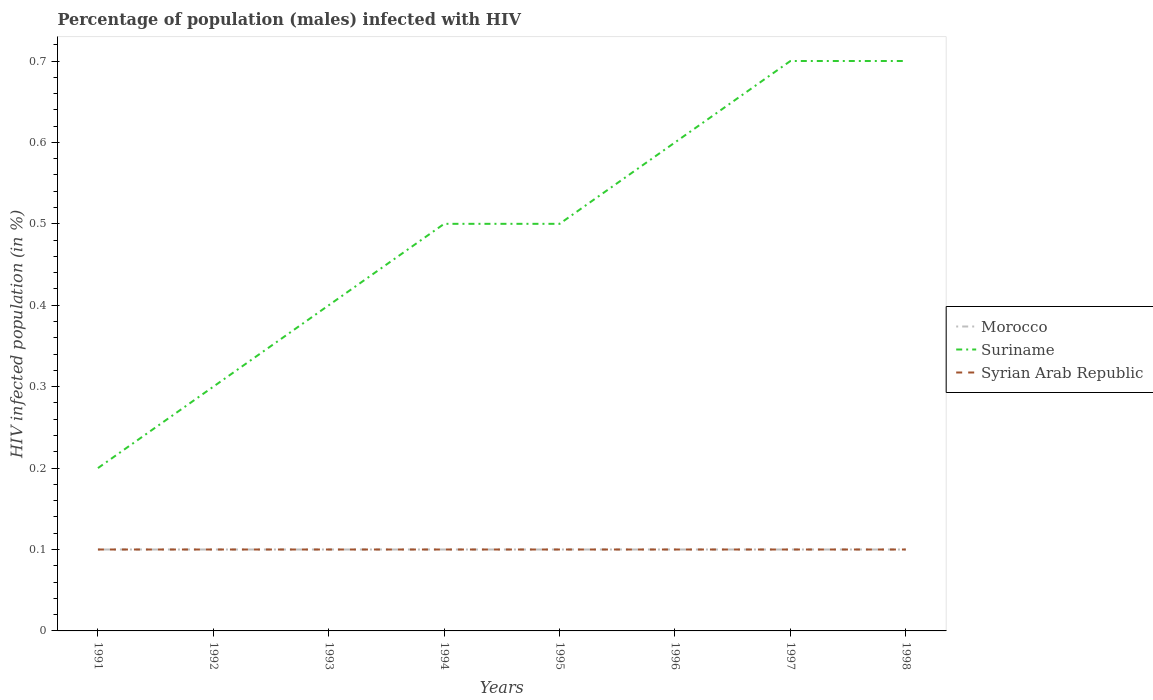Is the number of lines equal to the number of legend labels?
Your answer should be compact. Yes. Across all years, what is the maximum percentage of HIV infected male population in Suriname?
Your response must be concise. 0.2. In which year was the percentage of HIV infected male population in Suriname maximum?
Make the answer very short. 1991. What is the total percentage of HIV infected male population in Suriname in the graph?
Give a very brief answer. -0.1. What is the difference between the highest and the second highest percentage of HIV infected male population in Syrian Arab Republic?
Your answer should be very brief. 0. What is the difference between the highest and the lowest percentage of HIV infected male population in Syrian Arab Republic?
Your response must be concise. 0. Is the percentage of HIV infected male population in Syrian Arab Republic strictly greater than the percentage of HIV infected male population in Morocco over the years?
Your response must be concise. No. How many lines are there?
Ensure brevity in your answer.  3. How many years are there in the graph?
Ensure brevity in your answer.  8. What is the difference between two consecutive major ticks on the Y-axis?
Offer a terse response. 0.1. Does the graph contain any zero values?
Provide a short and direct response. No. How are the legend labels stacked?
Provide a succinct answer. Vertical. What is the title of the graph?
Make the answer very short. Percentage of population (males) infected with HIV. What is the label or title of the Y-axis?
Make the answer very short. HIV infected population (in %). What is the HIV infected population (in %) of Morocco in 1991?
Offer a terse response. 0.1. What is the HIV infected population (in %) of Suriname in 1992?
Provide a short and direct response. 0.3. What is the HIV infected population (in %) in Syrian Arab Republic in 1992?
Offer a terse response. 0.1. What is the HIV infected population (in %) of Morocco in 1993?
Your answer should be compact. 0.1. What is the HIV infected population (in %) in Syrian Arab Republic in 1993?
Provide a short and direct response. 0.1. What is the HIV infected population (in %) in Suriname in 1994?
Give a very brief answer. 0.5. What is the HIV infected population (in %) in Syrian Arab Republic in 1994?
Provide a short and direct response. 0.1. What is the HIV infected population (in %) in Suriname in 1995?
Make the answer very short. 0.5. What is the HIV infected population (in %) of Syrian Arab Republic in 1996?
Your response must be concise. 0.1. What is the HIV infected population (in %) in Morocco in 1997?
Offer a very short reply. 0.1. What is the HIV infected population (in %) in Suriname in 1997?
Ensure brevity in your answer.  0.7. What is the HIV infected population (in %) in Syrian Arab Republic in 1997?
Offer a very short reply. 0.1. What is the HIV infected population (in %) in Morocco in 1998?
Your response must be concise. 0.1. What is the HIV infected population (in %) in Suriname in 1998?
Make the answer very short. 0.7. Across all years, what is the maximum HIV infected population (in %) of Morocco?
Provide a succinct answer. 0.1. Across all years, what is the minimum HIV infected population (in %) in Syrian Arab Republic?
Provide a short and direct response. 0.1. What is the total HIV infected population (in %) of Morocco in the graph?
Offer a terse response. 0.8. What is the total HIV infected population (in %) of Suriname in the graph?
Your answer should be very brief. 3.9. What is the difference between the HIV infected population (in %) of Suriname in 1991 and that in 1992?
Provide a short and direct response. -0.1. What is the difference between the HIV infected population (in %) of Syrian Arab Republic in 1991 and that in 1992?
Offer a very short reply. 0. What is the difference between the HIV infected population (in %) of Suriname in 1991 and that in 1993?
Your answer should be compact. -0.2. What is the difference between the HIV infected population (in %) in Syrian Arab Republic in 1991 and that in 1993?
Ensure brevity in your answer.  0. What is the difference between the HIV infected population (in %) of Morocco in 1991 and that in 1994?
Provide a succinct answer. 0. What is the difference between the HIV infected population (in %) of Suriname in 1991 and that in 1994?
Provide a short and direct response. -0.3. What is the difference between the HIV infected population (in %) in Syrian Arab Republic in 1991 and that in 1994?
Provide a short and direct response. 0. What is the difference between the HIV infected population (in %) in Morocco in 1991 and that in 1995?
Offer a terse response. 0. What is the difference between the HIV infected population (in %) of Suriname in 1991 and that in 1995?
Offer a terse response. -0.3. What is the difference between the HIV infected population (in %) in Suriname in 1991 and that in 1997?
Give a very brief answer. -0.5. What is the difference between the HIV infected population (in %) of Syrian Arab Republic in 1991 and that in 1997?
Give a very brief answer. 0. What is the difference between the HIV infected population (in %) in Morocco in 1991 and that in 1998?
Offer a terse response. 0. What is the difference between the HIV infected population (in %) in Syrian Arab Republic in 1991 and that in 1998?
Your answer should be compact. 0. What is the difference between the HIV infected population (in %) of Morocco in 1992 and that in 1993?
Ensure brevity in your answer.  0. What is the difference between the HIV infected population (in %) of Suriname in 1992 and that in 1994?
Make the answer very short. -0.2. What is the difference between the HIV infected population (in %) of Morocco in 1992 and that in 1995?
Make the answer very short. 0. What is the difference between the HIV infected population (in %) of Suriname in 1992 and that in 1995?
Offer a terse response. -0.2. What is the difference between the HIV infected population (in %) of Morocco in 1992 and that in 1996?
Keep it short and to the point. 0. What is the difference between the HIV infected population (in %) in Suriname in 1992 and that in 1996?
Make the answer very short. -0.3. What is the difference between the HIV infected population (in %) of Syrian Arab Republic in 1992 and that in 1996?
Keep it short and to the point. 0. What is the difference between the HIV infected population (in %) of Morocco in 1992 and that in 1997?
Your answer should be compact. 0. What is the difference between the HIV infected population (in %) in Suriname in 1992 and that in 1997?
Make the answer very short. -0.4. What is the difference between the HIV infected population (in %) in Morocco in 1992 and that in 1998?
Offer a terse response. 0. What is the difference between the HIV infected population (in %) in Syrian Arab Republic in 1992 and that in 1998?
Provide a short and direct response. 0. What is the difference between the HIV infected population (in %) of Morocco in 1993 and that in 1994?
Your answer should be compact. 0. What is the difference between the HIV infected population (in %) in Syrian Arab Republic in 1993 and that in 1994?
Give a very brief answer. 0. What is the difference between the HIV infected population (in %) of Morocco in 1993 and that in 1996?
Make the answer very short. 0. What is the difference between the HIV infected population (in %) of Suriname in 1993 and that in 1996?
Keep it short and to the point. -0.2. What is the difference between the HIV infected population (in %) in Syrian Arab Republic in 1993 and that in 1996?
Make the answer very short. 0. What is the difference between the HIV infected population (in %) in Morocco in 1993 and that in 1997?
Provide a short and direct response. 0. What is the difference between the HIV infected population (in %) in Suriname in 1993 and that in 1997?
Provide a short and direct response. -0.3. What is the difference between the HIV infected population (in %) in Syrian Arab Republic in 1993 and that in 1997?
Keep it short and to the point. 0. What is the difference between the HIV infected population (in %) of Morocco in 1993 and that in 1998?
Your answer should be very brief. 0. What is the difference between the HIV infected population (in %) in Suriname in 1993 and that in 1998?
Give a very brief answer. -0.3. What is the difference between the HIV infected population (in %) of Syrian Arab Republic in 1994 and that in 1995?
Give a very brief answer. 0. What is the difference between the HIV infected population (in %) of Syrian Arab Republic in 1994 and that in 1996?
Your response must be concise. 0. What is the difference between the HIV infected population (in %) of Morocco in 1994 and that in 1997?
Your answer should be very brief. 0. What is the difference between the HIV infected population (in %) of Suriname in 1994 and that in 1998?
Keep it short and to the point. -0.2. What is the difference between the HIV infected population (in %) in Suriname in 1995 and that in 1996?
Give a very brief answer. -0.1. What is the difference between the HIV infected population (in %) of Syrian Arab Republic in 1995 and that in 1997?
Provide a short and direct response. 0. What is the difference between the HIV infected population (in %) in Morocco in 1996 and that in 1997?
Give a very brief answer. 0. What is the difference between the HIV infected population (in %) in Syrian Arab Republic in 1996 and that in 1997?
Offer a very short reply. 0. What is the difference between the HIV infected population (in %) of Morocco in 1996 and that in 1998?
Offer a terse response. 0. What is the difference between the HIV infected population (in %) of Suriname in 1996 and that in 1998?
Give a very brief answer. -0.1. What is the difference between the HIV infected population (in %) in Suriname in 1997 and that in 1998?
Your answer should be compact. 0. What is the difference between the HIV infected population (in %) of Syrian Arab Republic in 1997 and that in 1998?
Ensure brevity in your answer.  0. What is the difference between the HIV infected population (in %) in Morocco in 1991 and the HIV infected population (in %) in Suriname in 1992?
Offer a very short reply. -0.2. What is the difference between the HIV infected population (in %) in Morocco in 1991 and the HIV infected population (in %) in Syrian Arab Republic in 1992?
Your answer should be compact. 0. What is the difference between the HIV infected population (in %) of Suriname in 1991 and the HIV infected population (in %) of Syrian Arab Republic in 1992?
Provide a succinct answer. 0.1. What is the difference between the HIV infected population (in %) in Morocco in 1991 and the HIV infected population (in %) in Suriname in 1993?
Give a very brief answer. -0.3. What is the difference between the HIV infected population (in %) in Suriname in 1991 and the HIV infected population (in %) in Syrian Arab Republic in 1993?
Your answer should be compact. 0.1. What is the difference between the HIV infected population (in %) of Morocco in 1991 and the HIV infected population (in %) of Suriname in 1994?
Provide a short and direct response. -0.4. What is the difference between the HIV infected population (in %) of Morocco in 1991 and the HIV infected population (in %) of Syrian Arab Republic in 1994?
Your answer should be compact. 0. What is the difference between the HIV infected population (in %) in Morocco in 1991 and the HIV infected population (in %) in Suriname in 1995?
Your response must be concise. -0.4. What is the difference between the HIV infected population (in %) of Morocco in 1991 and the HIV infected population (in %) of Syrian Arab Republic in 1995?
Make the answer very short. 0. What is the difference between the HIV infected population (in %) in Suriname in 1991 and the HIV infected population (in %) in Syrian Arab Republic in 1995?
Give a very brief answer. 0.1. What is the difference between the HIV infected population (in %) of Morocco in 1991 and the HIV infected population (in %) of Syrian Arab Republic in 1997?
Ensure brevity in your answer.  0. What is the difference between the HIV infected population (in %) of Suriname in 1991 and the HIV infected population (in %) of Syrian Arab Republic in 1997?
Make the answer very short. 0.1. What is the difference between the HIV infected population (in %) of Morocco in 1991 and the HIV infected population (in %) of Suriname in 1998?
Provide a short and direct response. -0.6. What is the difference between the HIV infected population (in %) in Morocco in 1991 and the HIV infected population (in %) in Syrian Arab Republic in 1998?
Provide a succinct answer. 0. What is the difference between the HIV infected population (in %) in Morocco in 1992 and the HIV infected population (in %) in Syrian Arab Republic in 1993?
Your answer should be very brief. 0. What is the difference between the HIV infected population (in %) in Suriname in 1992 and the HIV infected population (in %) in Syrian Arab Republic in 1993?
Offer a very short reply. 0.2. What is the difference between the HIV infected population (in %) in Morocco in 1992 and the HIV infected population (in %) in Suriname in 1994?
Provide a succinct answer. -0.4. What is the difference between the HIV infected population (in %) in Morocco in 1992 and the HIV infected population (in %) in Syrian Arab Republic in 1994?
Give a very brief answer. 0. What is the difference between the HIV infected population (in %) of Suriname in 1992 and the HIV infected population (in %) of Syrian Arab Republic in 1994?
Give a very brief answer. 0.2. What is the difference between the HIV infected population (in %) of Morocco in 1992 and the HIV infected population (in %) of Suriname in 1995?
Offer a very short reply. -0.4. What is the difference between the HIV infected population (in %) in Morocco in 1992 and the HIV infected population (in %) in Syrian Arab Republic in 1995?
Make the answer very short. 0. What is the difference between the HIV infected population (in %) of Suriname in 1992 and the HIV infected population (in %) of Syrian Arab Republic in 1996?
Ensure brevity in your answer.  0.2. What is the difference between the HIV infected population (in %) in Morocco in 1992 and the HIV infected population (in %) in Suriname in 1997?
Provide a short and direct response. -0.6. What is the difference between the HIV infected population (in %) in Morocco in 1992 and the HIV infected population (in %) in Syrian Arab Republic in 1997?
Provide a succinct answer. 0. What is the difference between the HIV infected population (in %) in Suriname in 1992 and the HIV infected population (in %) in Syrian Arab Republic in 1997?
Offer a very short reply. 0.2. What is the difference between the HIV infected population (in %) in Morocco in 1992 and the HIV infected population (in %) in Syrian Arab Republic in 1998?
Make the answer very short. 0. What is the difference between the HIV infected population (in %) in Suriname in 1993 and the HIV infected population (in %) in Syrian Arab Republic in 1994?
Give a very brief answer. 0.3. What is the difference between the HIV infected population (in %) of Morocco in 1993 and the HIV infected population (in %) of Suriname in 1995?
Provide a short and direct response. -0.4. What is the difference between the HIV infected population (in %) of Morocco in 1993 and the HIV infected population (in %) of Suriname in 1996?
Provide a succinct answer. -0.5. What is the difference between the HIV infected population (in %) in Suriname in 1993 and the HIV infected population (in %) in Syrian Arab Republic in 1996?
Your response must be concise. 0.3. What is the difference between the HIV infected population (in %) of Morocco in 1993 and the HIV infected population (in %) of Suriname in 1997?
Provide a short and direct response. -0.6. What is the difference between the HIV infected population (in %) of Morocco in 1993 and the HIV infected population (in %) of Syrian Arab Republic in 1997?
Keep it short and to the point. 0. What is the difference between the HIV infected population (in %) of Suriname in 1994 and the HIV infected population (in %) of Syrian Arab Republic in 1995?
Make the answer very short. 0.4. What is the difference between the HIV infected population (in %) in Morocco in 1994 and the HIV infected population (in %) in Syrian Arab Republic in 1996?
Ensure brevity in your answer.  0. What is the difference between the HIV infected population (in %) of Morocco in 1994 and the HIV infected population (in %) of Syrian Arab Republic in 1997?
Your answer should be very brief. 0. What is the difference between the HIV infected population (in %) of Morocco in 1994 and the HIV infected population (in %) of Suriname in 1998?
Offer a terse response. -0.6. What is the difference between the HIV infected population (in %) of Morocco in 1994 and the HIV infected population (in %) of Syrian Arab Republic in 1998?
Your answer should be compact. 0. What is the difference between the HIV infected population (in %) in Morocco in 1995 and the HIV infected population (in %) in Suriname in 1997?
Your response must be concise. -0.6. What is the difference between the HIV infected population (in %) of Suriname in 1995 and the HIV infected population (in %) of Syrian Arab Republic in 1997?
Make the answer very short. 0.4. What is the difference between the HIV infected population (in %) in Morocco in 1995 and the HIV infected population (in %) in Syrian Arab Republic in 1998?
Your answer should be very brief. 0. What is the difference between the HIV infected population (in %) of Suriname in 1995 and the HIV infected population (in %) of Syrian Arab Republic in 1998?
Give a very brief answer. 0.4. What is the difference between the HIV infected population (in %) in Morocco in 1996 and the HIV infected population (in %) in Suriname in 1997?
Offer a terse response. -0.6. What is the difference between the HIV infected population (in %) of Morocco in 1996 and the HIV infected population (in %) of Suriname in 1998?
Your answer should be compact. -0.6. What is the difference between the HIV infected population (in %) of Morocco in 1996 and the HIV infected population (in %) of Syrian Arab Republic in 1998?
Your answer should be compact. 0. What is the difference between the HIV infected population (in %) of Suriname in 1996 and the HIV infected population (in %) of Syrian Arab Republic in 1998?
Give a very brief answer. 0.5. What is the average HIV infected population (in %) of Suriname per year?
Provide a succinct answer. 0.49. What is the average HIV infected population (in %) in Syrian Arab Republic per year?
Make the answer very short. 0.1. In the year 1991, what is the difference between the HIV infected population (in %) of Morocco and HIV infected population (in %) of Suriname?
Give a very brief answer. -0.1. In the year 1991, what is the difference between the HIV infected population (in %) of Suriname and HIV infected population (in %) of Syrian Arab Republic?
Your answer should be very brief. 0.1. In the year 1993, what is the difference between the HIV infected population (in %) of Morocco and HIV infected population (in %) of Suriname?
Your response must be concise. -0.3. In the year 1993, what is the difference between the HIV infected population (in %) of Suriname and HIV infected population (in %) of Syrian Arab Republic?
Keep it short and to the point. 0.3. In the year 1994, what is the difference between the HIV infected population (in %) in Suriname and HIV infected population (in %) in Syrian Arab Republic?
Keep it short and to the point. 0.4. In the year 1996, what is the difference between the HIV infected population (in %) of Morocco and HIV infected population (in %) of Suriname?
Provide a short and direct response. -0.5. In the year 1996, what is the difference between the HIV infected population (in %) in Suriname and HIV infected population (in %) in Syrian Arab Republic?
Your answer should be compact. 0.5. In the year 1997, what is the difference between the HIV infected population (in %) of Morocco and HIV infected population (in %) of Suriname?
Give a very brief answer. -0.6. In the year 1998, what is the difference between the HIV infected population (in %) of Morocco and HIV infected population (in %) of Syrian Arab Republic?
Ensure brevity in your answer.  0. What is the ratio of the HIV infected population (in %) in Syrian Arab Republic in 1991 to that in 1992?
Keep it short and to the point. 1. What is the ratio of the HIV infected population (in %) of Syrian Arab Republic in 1991 to that in 1993?
Ensure brevity in your answer.  1. What is the ratio of the HIV infected population (in %) of Morocco in 1991 to that in 1994?
Ensure brevity in your answer.  1. What is the ratio of the HIV infected population (in %) of Syrian Arab Republic in 1991 to that in 1994?
Give a very brief answer. 1. What is the ratio of the HIV infected population (in %) of Morocco in 1991 to that in 1995?
Provide a succinct answer. 1. What is the ratio of the HIV infected population (in %) in Suriname in 1991 to that in 1995?
Your answer should be very brief. 0.4. What is the ratio of the HIV infected population (in %) in Suriname in 1991 to that in 1996?
Offer a terse response. 0.33. What is the ratio of the HIV infected population (in %) in Morocco in 1991 to that in 1997?
Ensure brevity in your answer.  1. What is the ratio of the HIV infected population (in %) in Suriname in 1991 to that in 1997?
Give a very brief answer. 0.29. What is the ratio of the HIV infected population (in %) in Syrian Arab Republic in 1991 to that in 1997?
Give a very brief answer. 1. What is the ratio of the HIV infected population (in %) in Suriname in 1991 to that in 1998?
Offer a terse response. 0.29. What is the ratio of the HIV infected population (in %) of Suriname in 1992 to that in 1994?
Ensure brevity in your answer.  0.6. What is the ratio of the HIV infected population (in %) of Morocco in 1992 to that in 1995?
Give a very brief answer. 1. What is the ratio of the HIV infected population (in %) of Suriname in 1992 to that in 1995?
Offer a very short reply. 0.6. What is the ratio of the HIV infected population (in %) of Syrian Arab Republic in 1992 to that in 1995?
Keep it short and to the point. 1. What is the ratio of the HIV infected population (in %) in Syrian Arab Republic in 1992 to that in 1996?
Ensure brevity in your answer.  1. What is the ratio of the HIV infected population (in %) of Suriname in 1992 to that in 1997?
Offer a terse response. 0.43. What is the ratio of the HIV infected population (in %) of Syrian Arab Republic in 1992 to that in 1997?
Your answer should be very brief. 1. What is the ratio of the HIV infected population (in %) of Suriname in 1992 to that in 1998?
Offer a very short reply. 0.43. What is the ratio of the HIV infected population (in %) in Morocco in 1993 to that in 1994?
Your answer should be compact. 1. What is the ratio of the HIV infected population (in %) in Suriname in 1993 to that in 1994?
Give a very brief answer. 0.8. What is the ratio of the HIV infected population (in %) in Suriname in 1993 to that in 1995?
Keep it short and to the point. 0.8. What is the ratio of the HIV infected population (in %) in Morocco in 1993 to that in 1997?
Your response must be concise. 1. What is the ratio of the HIV infected population (in %) in Syrian Arab Republic in 1993 to that in 1997?
Provide a short and direct response. 1. What is the ratio of the HIV infected population (in %) in Morocco in 1993 to that in 1998?
Offer a very short reply. 1. What is the ratio of the HIV infected population (in %) of Suriname in 1993 to that in 1998?
Provide a short and direct response. 0.57. What is the ratio of the HIV infected population (in %) of Syrian Arab Republic in 1993 to that in 1998?
Make the answer very short. 1. What is the ratio of the HIV infected population (in %) of Suriname in 1994 to that in 1997?
Make the answer very short. 0.71. What is the ratio of the HIV infected population (in %) in Morocco in 1994 to that in 1998?
Provide a succinct answer. 1. What is the ratio of the HIV infected population (in %) in Suriname in 1994 to that in 1998?
Ensure brevity in your answer.  0.71. What is the ratio of the HIV infected population (in %) in Syrian Arab Republic in 1994 to that in 1998?
Give a very brief answer. 1. What is the ratio of the HIV infected population (in %) of Morocco in 1995 to that in 1996?
Provide a short and direct response. 1. What is the ratio of the HIV infected population (in %) of Syrian Arab Republic in 1995 to that in 1996?
Offer a very short reply. 1. What is the ratio of the HIV infected population (in %) of Suriname in 1995 to that in 1997?
Offer a very short reply. 0.71. What is the ratio of the HIV infected population (in %) of Syrian Arab Republic in 1995 to that in 1997?
Provide a short and direct response. 1. What is the ratio of the HIV infected population (in %) of Morocco in 1996 to that in 1997?
Your answer should be compact. 1. What is the ratio of the HIV infected population (in %) of Suriname in 1996 to that in 1997?
Your response must be concise. 0.86. What is the ratio of the HIV infected population (in %) of Syrian Arab Republic in 1996 to that in 1997?
Keep it short and to the point. 1. What is the ratio of the HIV infected population (in %) of Morocco in 1996 to that in 1998?
Your response must be concise. 1. What is the ratio of the HIV infected population (in %) of Syrian Arab Republic in 1996 to that in 1998?
Your answer should be very brief. 1. What is the difference between the highest and the second highest HIV infected population (in %) of Morocco?
Offer a very short reply. 0. What is the difference between the highest and the second highest HIV infected population (in %) of Syrian Arab Republic?
Make the answer very short. 0. What is the difference between the highest and the lowest HIV infected population (in %) of Suriname?
Provide a succinct answer. 0.5. 